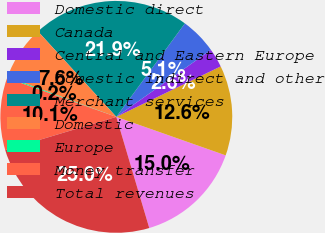Convert chart. <chart><loc_0><loc_0><loc_500><loc_500><pie_chart><fcel>Domestic direct<fcel>Canada<fcel>Central and Eastern Europe<fcel>Domestic indirect and other<fcel>Merchant services<fcel>Domestic<fcel>Europe<fcel>Money transfer<fcel>Total revenues<nl><fcel>15.03%<fcel>12.55%<fcel>2.64%<fcel>5.12%<fcel>21.88%<fcel>7.6%<fcel>0.16%<fcel>10.07%<fcel>24.95%<nl></chart> 